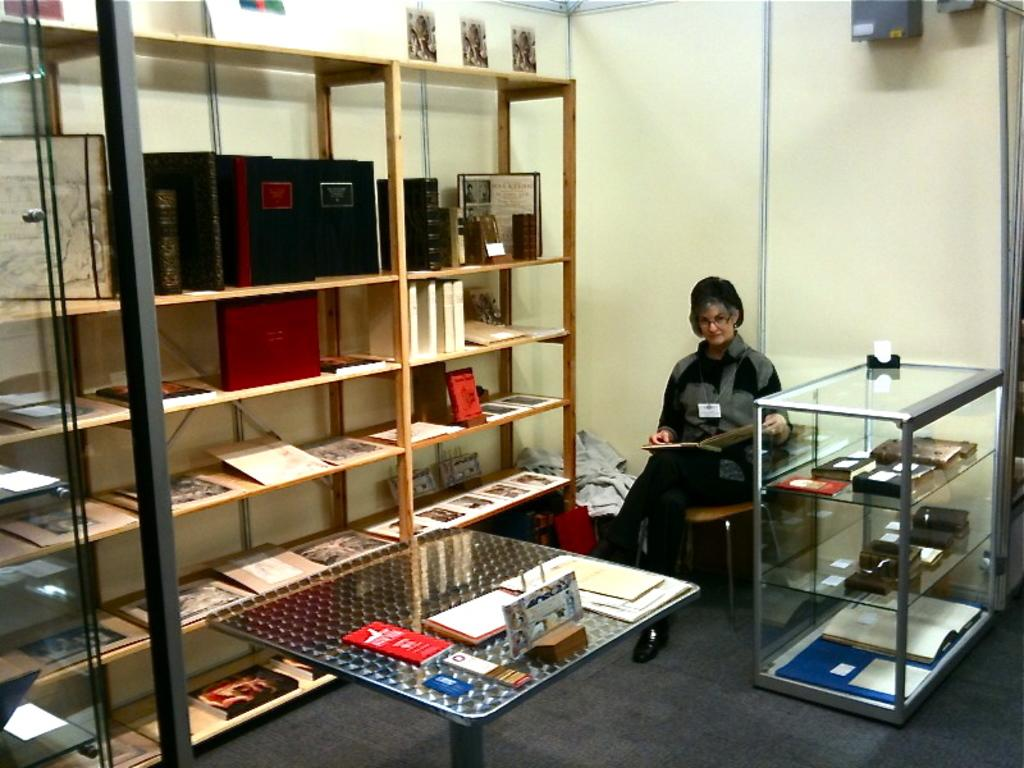Who is the main subject in the image? There is a woman in the image. What is the woman doing in the image? The woman is sitting on a chair and holding a book in her hands. What can be seen in the background of the image? There are objects arranged in cupboards, on a table, and on the walls. Can you see the woman kissing someone in the image? No, there is no indication of a kiss or another person in the image. How does the woman balance the book on her head in the image? The woman is not balancing the book on her head in the image; she is simply holding it in her hands. 